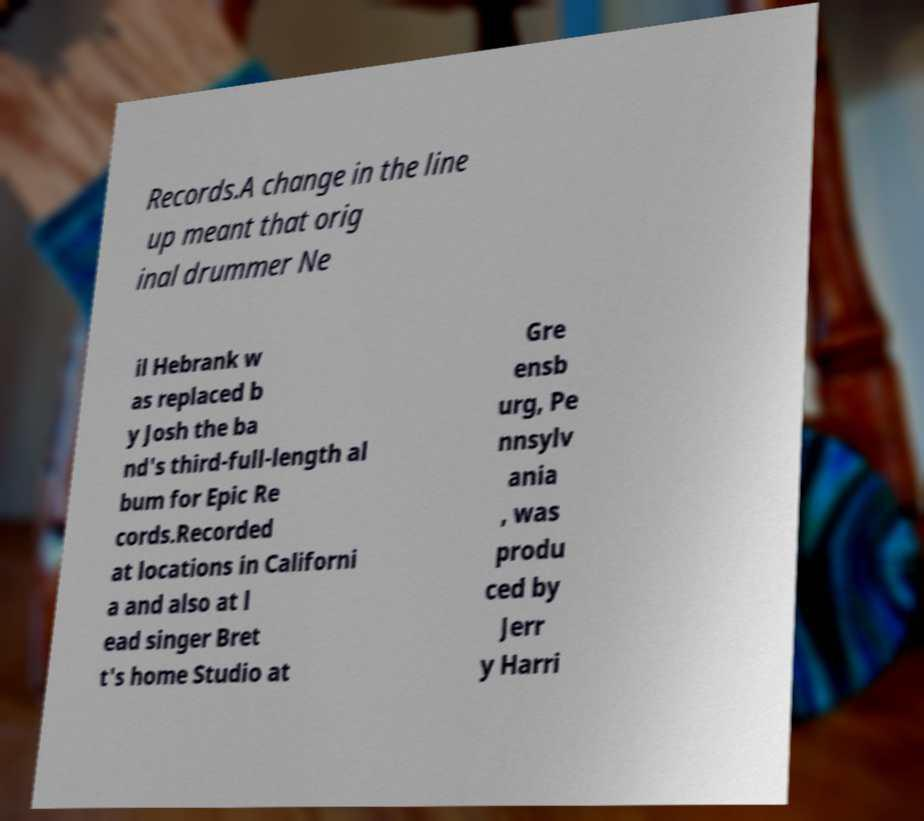Please identify and transcribe the text found in this image. Records.A change in the line up meant that orig inal drummer Ne il Hebrank w as replaced b y Josh the ba nd's third-full-length al bum for Epic Re cords.Recorded at locations in Californi a and also at l ead singer Bret t's home Studio at Gre ensb urg, Pe nnsylv ania , was produ ced by Jerr y Harri 